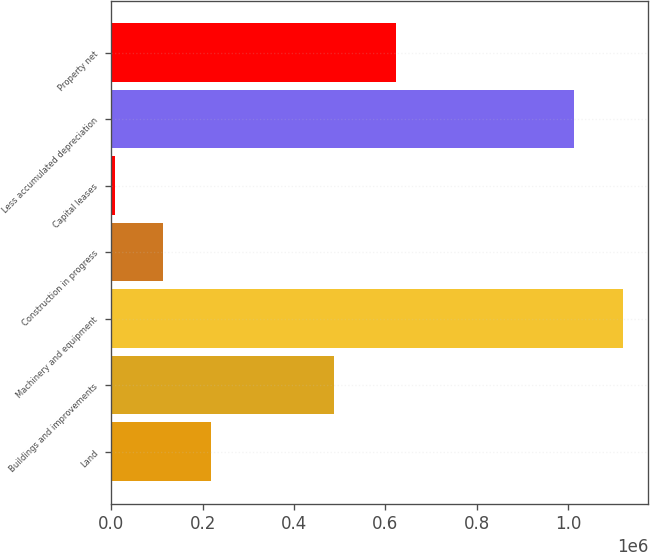<chart> <loc_0><loc_0><loc_500><loc_500><bar_chart><fcel>Land<fcel>Buildings and improvements<fcel>Machinery and equipment<fcel>Construction in progress<fcel>Capital leases<fcel>Less accumulated depreciation<fcel>Property net<nl><fcel>218439<fcel>486893<fcel>1.11915e+06<fcel>112786<fcel>7133<fcel>1.0135e+06<fcel>623991<nl></chart> 